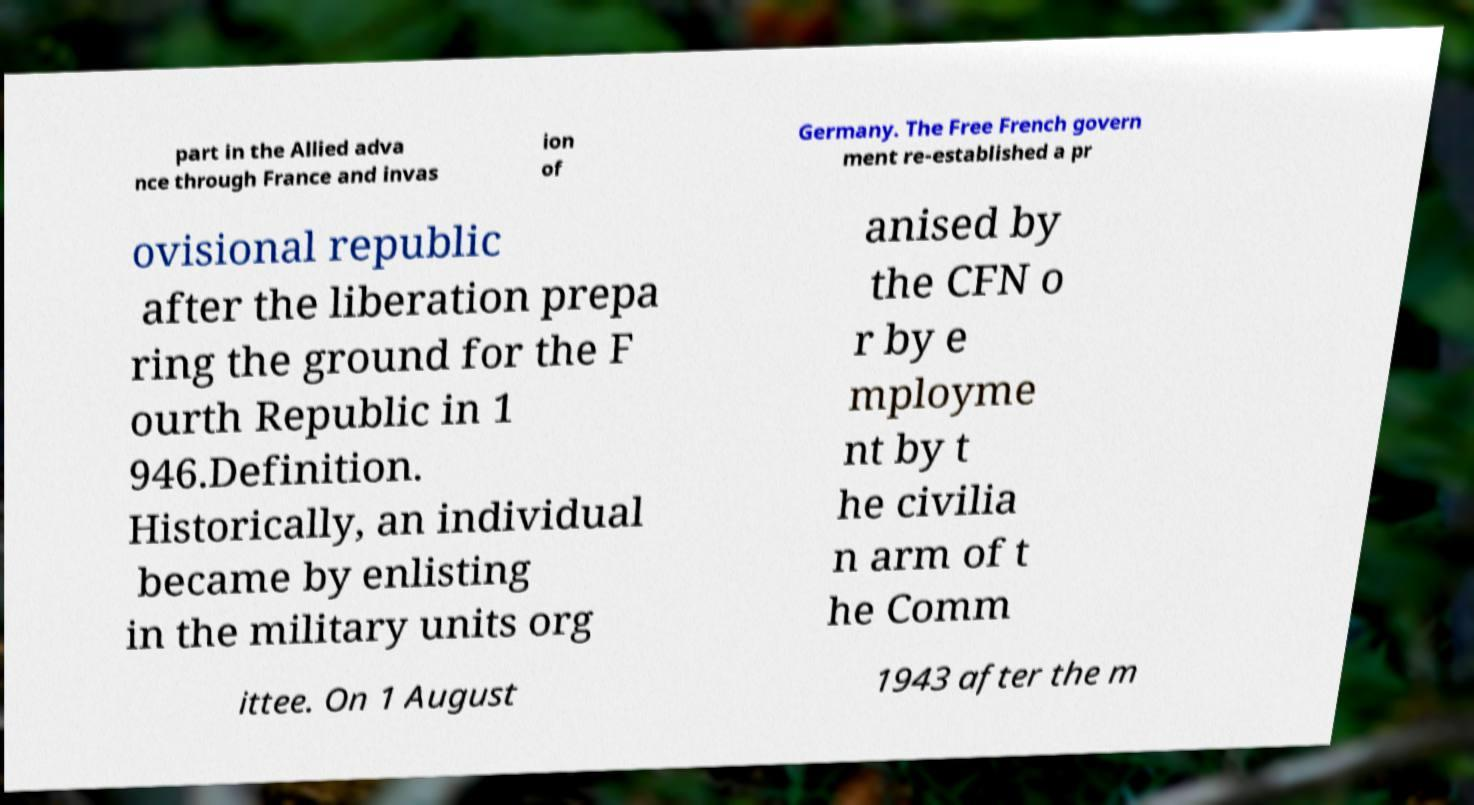Please read and relay the text visible in this image. What does it say? part in the Allied adva nce through France and invas ion of Germany. The Free French govern ment re-established a pr ovisional republic after the liberation prepa ring the ground for the F ourth Republic in 1 946.Definition. Historically, an individual became by enlisting in the military units org anised by the CFN o r by e mployme nt by t he civilia n arm of t he Comm ittee. On 1 August 1943 after the m 